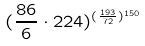<formula> <loc_0><loc_0><loc_500><loc_500>( \frac { 8 6 } { 6 } \cdot 2 2 4 ) ^ { ( \frac { 1 9 3 } { 7 2 } ) ^ { 1 5 0 } }</formula> 